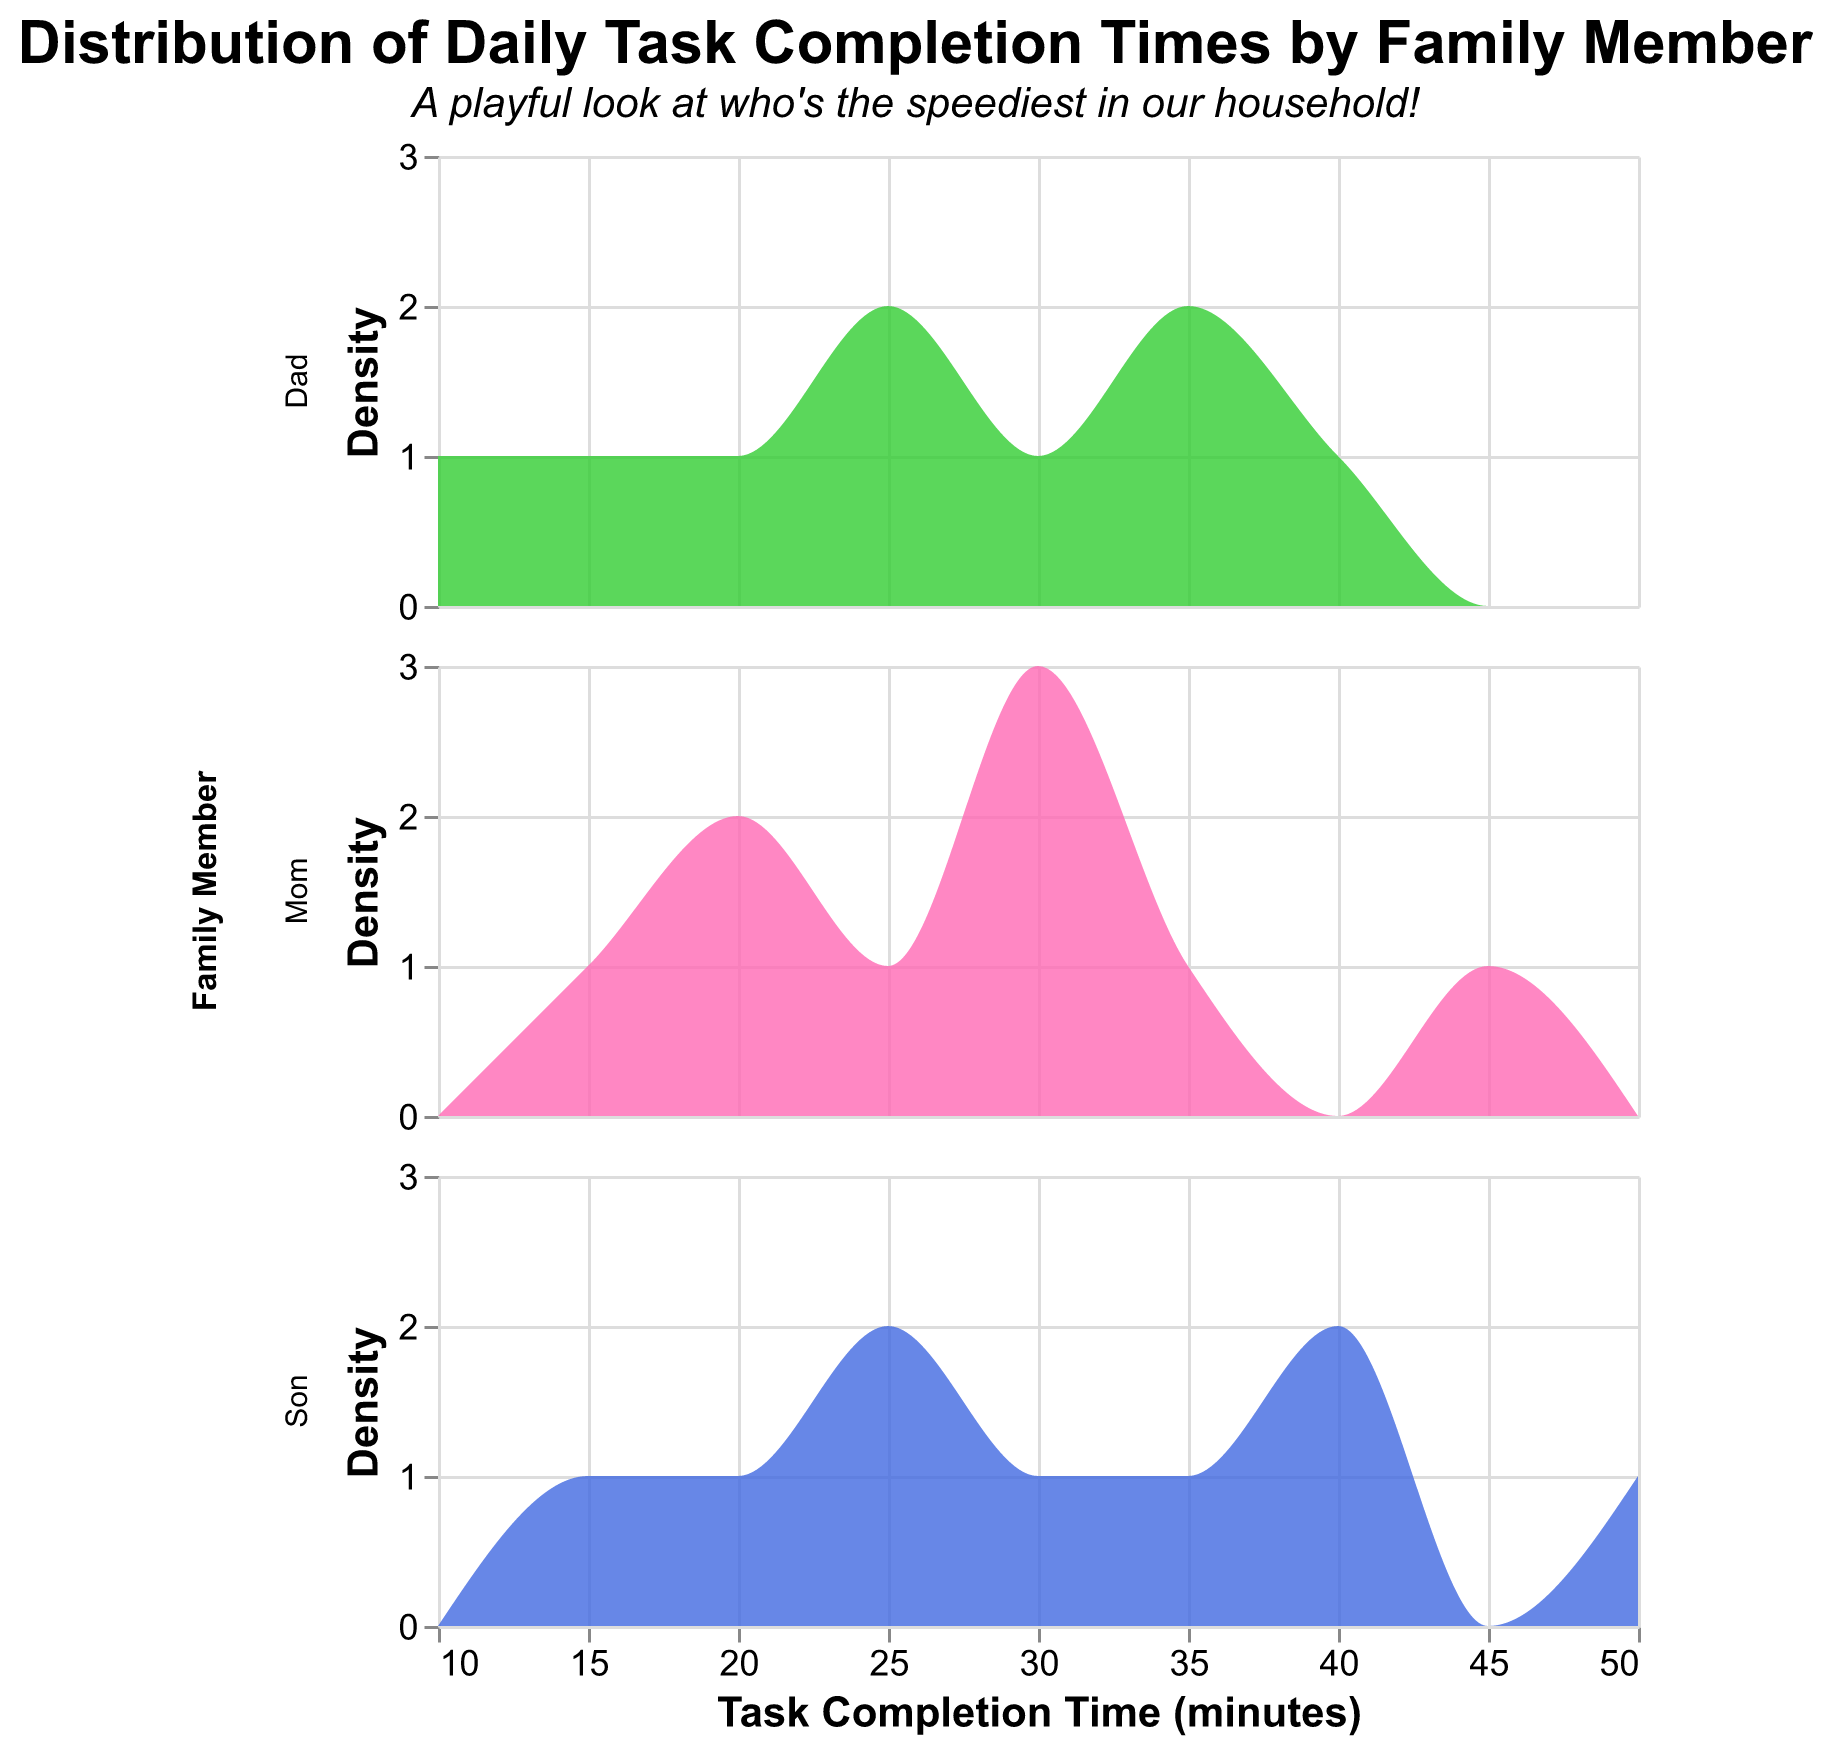Which color represents "Dad" in the plot? The plot legend shows that "Dad" is represented by a green color.
Answer: Green What does the y-axis represent in the plot? The y-axis of the plot is labeled "Density," indicating it represents the density of task completion times.
Answer: Density How long did it take Mom to help with homework? By looking at the data for "Help_With_Homework," we see that Mom's completion time is 35 minutes.
Answer: 35 minutes Which family member took the longest time to do laundry? By referring to the data for the "Do_Laundry" task, Son took the longest time, which is 40 minutes.
Answer: Son Whose task completion times are the most uniformly distributed? Observing the density distribution, Dad's completion times appear to be fairly uniform compared to Mom's and Son's.
Answer: Dad How does Mom's grocery shopping time compare to Son's grocery shopping time? For the "Grocery_Shopping" task, Mom takes 45 minutes while Son takes 50 minutes. Thus, Son takes 5 minutes more than Mom.
Answer: Son takes longer Which family member completes most tasks in the shortest time? Referring to the density plots, Dad often completes tasks in the shortest time among the family members.
Answer: Dad On average, how much longer does Son take to clean his room compared to Dad? Son takes 25 minutes while Dad takes 15 minutes to clean the room. The difference is 25 - 15 = 10 minutes.
Answer: 10 minutes Comparing "Exercise" time, who is the fastest, and how much quicker are they compared to the slowest person? For the "Exercise" task, Son is the fastest with 25 minutes and Dad is the slowest with 35 minutes. The difference is 35 - 25 = 10 minutes.
Answer: Son, 10 minutes Which task has the highest average completion time for the entire family? For each task, we calculate the average time:  
- Make_Breakfast: (15+20+10)/3 = 15 minutes  
- Make_Lunch: (25+30+20)/3 = 25 minutes  
- Do_Laundry: (30+40+35)/3 = 35 minutes  
- Clean_Room: (20+25+15)/3 = 20 minutes  
- Grocery_Shopping: (45+50+40)/3 = 45 minutes  
- Help_With_Homework: (35+40+30)/3 = 35 minutes  
- Gardening: (30+35+25)/3 = 30 minutes  
- Play_with_Pet: (20+15+25)/3 = 20 minutes  
- Exercise: (30+25+35)/3 = 30 minutes  
The task "Grocery_Shopping" has the highest average completion time of 45 minutes.
Answer: Grocery_Shopping 